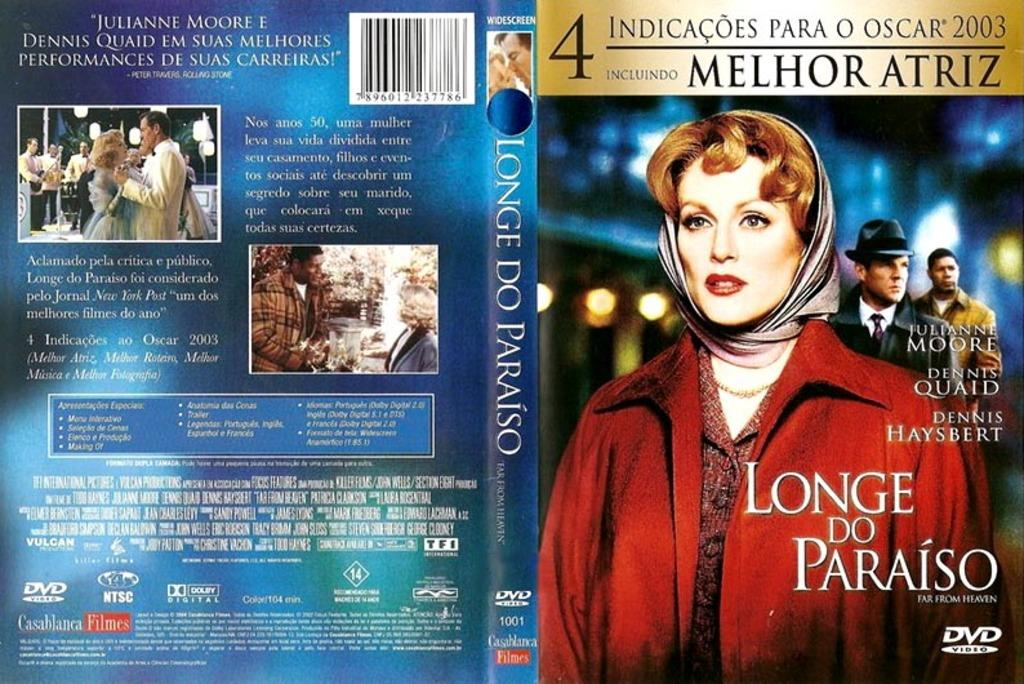<image>
Share a concise interpretation of the image provided. The cover of the movie Longe Do Paraiso. 